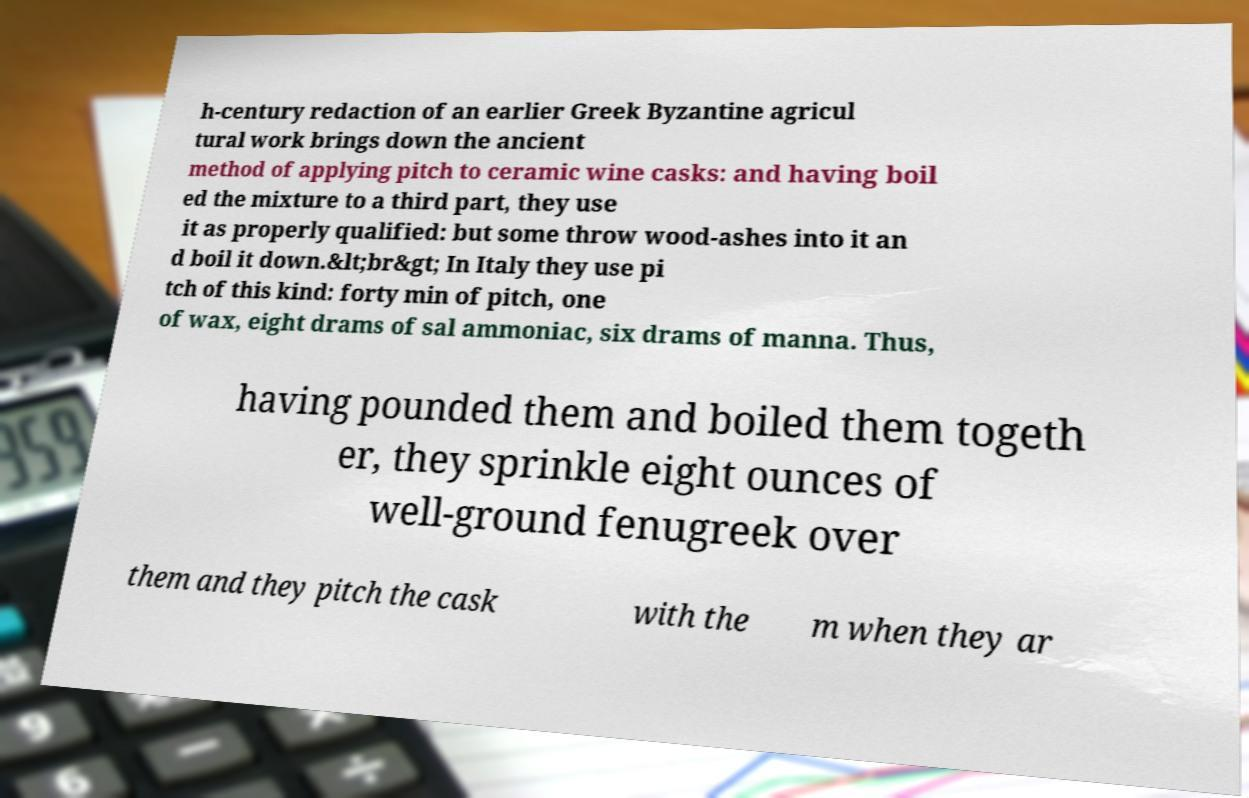Can you accurately transcribe the text from the provided image for me? h-century redaction of an earlier Greek Byzantine agricul tural work brings down the ancient method of applying pitch to ceramic wine casks: and having boil ed the mixture to a third part, they use it as properly qualified: but some throw wood-ashes into it an d boil it down.&lt;br&gt; In Italy they use pi tch of this kind: forty min of pitch, one of wax, eight drams of sal ammoniac, six drams of manna. Thus, having pounded them and boiled them togeth er, they sprinkle eight ounces of well-ground fenugreek over them and they pitch the cask with the m when they ar 